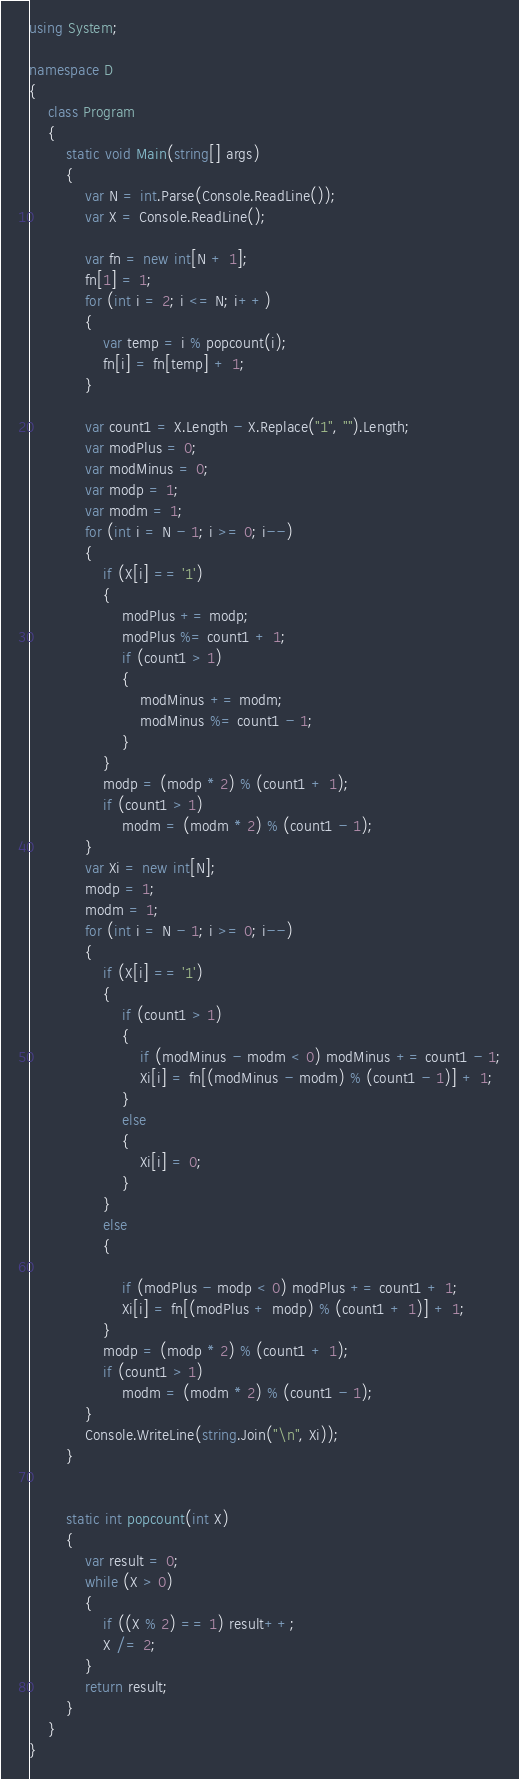<code> <loc_0><loc_0><loc_500><loc_500><_C#_>using System;

namespace D
{
    class Program
    {
        static void Main(string[] args)
        {
            var N = int.Parse(Console.ReadLine());
            var X = Console.ReadLine();

            var fn = new int[N + 1];
            fn[1] = 1;
            for (int i = 2; i <= N; i++)
            {
                var temp = i % popcount(i);
                fn[i] = fn[temp] + 1;
            }

            var count1 = X.Length - X.Replace("1", "").Length;
            var modPlus = 0;
            var modMinus = 0;
            var modp = 1;
            var modm = 1;
            for (int i = N - 1; i >= 0; i--)
            {
                if (X[i] == '1')
                {
                    modPlus += modp;
                    modPlus %= count1 + 1;
                    if (count1 > 1)
                    {
                        modMinus += modm;
                        modMinus %= count1 - 1;
                    }
                }
                modp = (modp * 2) % (count1 + 1);
                if (count1 > 1)
                    modm = (modm * 2) % (count1 - 1);
            }
            var Xi = new int[N];
            modp = 1;
            modm = 1;
            for (int i = N - 1; i >= 0; i--)
            {
                if (X[i] == '1')
                {
                    if (count1 > 1)
                    {
                        if (modMinus - modm < 0) modMinus += count1 - 1;
                        Xi[i] = fn[(modMinus - modm) % (count1 - 1)] + 1;
                    }
                    else
                    {
                        Xi[i] = 0;
                    }
                }
                else
                {

                    if (modPlus - modp < 0) modPlus += count1 + 1;
                    Xi[i] = fn[(modPlus + modp) % (count1 + 1)] + 1;
                }
                modp = (modp * 2) % (count1 + 1);
                if (count1 > 1)
                    modm = (modm * 2) % (count1 - 1);
            }
            Console.WriteLine(string.Join("\n", Xi));
        }


        static int popcount(int X)
        {
            var result = 0;
            while (X > 0)
            {
                if ((X % 2) == 1) result++;
                X /= 2;
            }
            return result;
        }
    }
}
</code> 